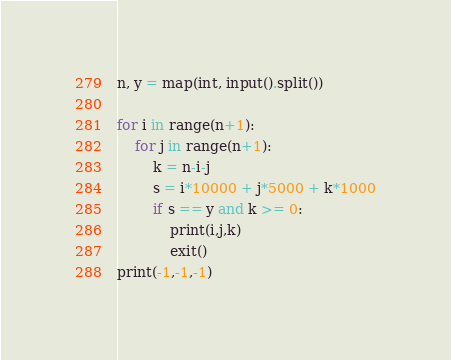<code> <loc_0><loc_0><loc_500><loc_500><_Python_>n, y = map(int, input().split())

for i in range(n+1):
    for j in range(n+1):
        k = n-i-j
        s = i*10000 + j*5000 + k*1000
        if s == y and k >= 0:
            print(i,j,k)
            exit()
print(-1,-1,-1)</code> 